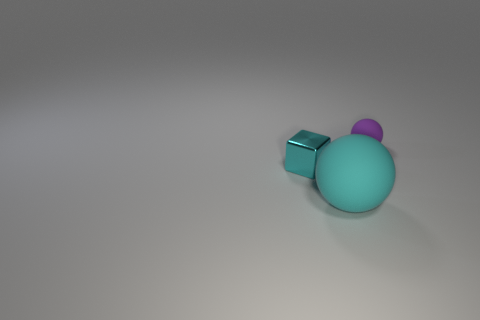What is the shape of the shiny thing that is the same color as the large rubber sphere?
Make the answer very short. Cube. There is a rubber sphere behind the small metallic block; does it have the same color as the large ball?
Keep it short and to the point. No. How many objects are objects that are left of the big matte object or balls that are to the left of the tiny rubber sphere?
Offer a very short reply. 2. How many things are both behind the large cyan sphere and in front of the purple sphere?
Give a very brief answer. 1. Are the purple sphere and the cyan ball made of the same material?
Provide a succinct answer. Yes. There is a small thing in front of the small thing that is on the right side of the large cyan sphere in front of the small sphere; what is its shape?
Keep it short and to the point. Cube. There is a thing that is behind the cyan matte ball and right of the metallic object; what is its material?
Ensure brevity in your answer.  Rubber. The matte thing on the right side of the rubber thing in front of the rubber ball behind the cyan sphere is what color?
Your response must be concise. Purple. How many green things are either shiny things or rubber balls?
Provide a succinct answer. 0. What number of other things are the same size as the cyan matte object?
Give a very brief answer. 0. 